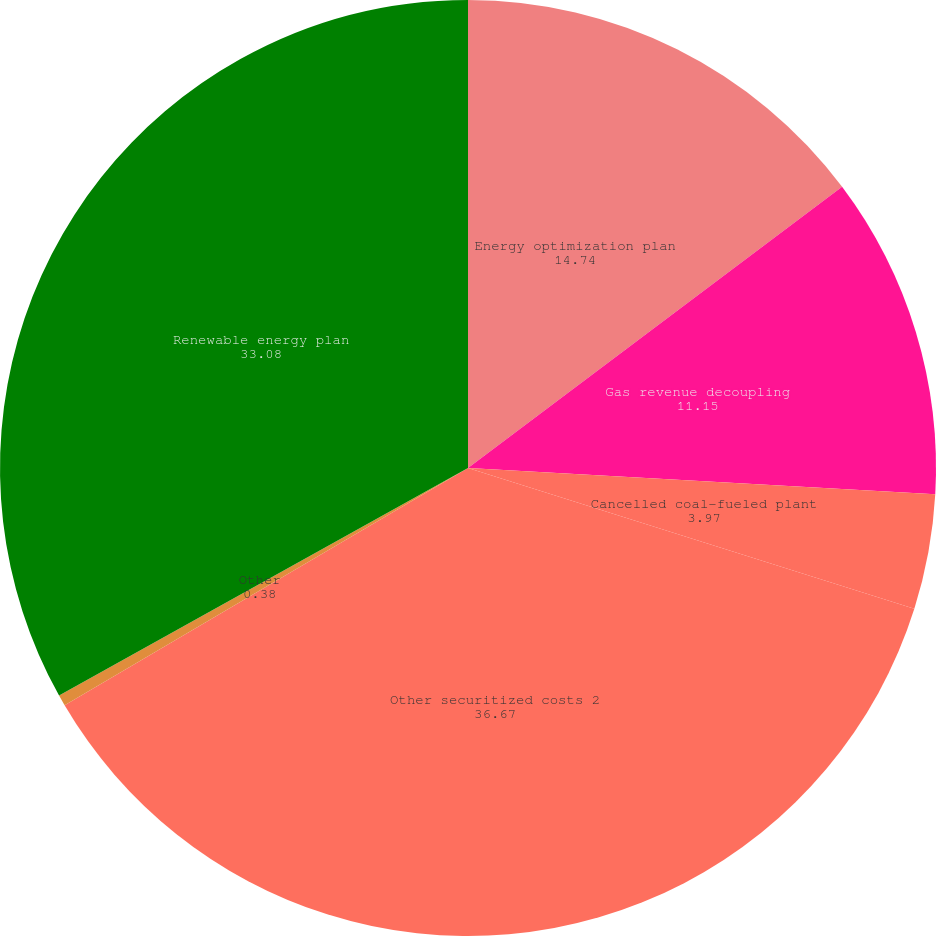Convert chart. <chart><loc_0><loc_0><loc_500><loc_500><pie_chart><fcel>Energy optimization plan<fcel>Gas revenue decoupling<fcel>Cancelled coal-fueled plant<fcel>Other securitized costs 2<fcel>Other<fcel>Renewable energy plan<nl><fcel>14.74%<fcel>11.15%<fcel>3.97%<fcel>36.67%<fcel>0.38%<fcel>33.08%<nl></chart> 